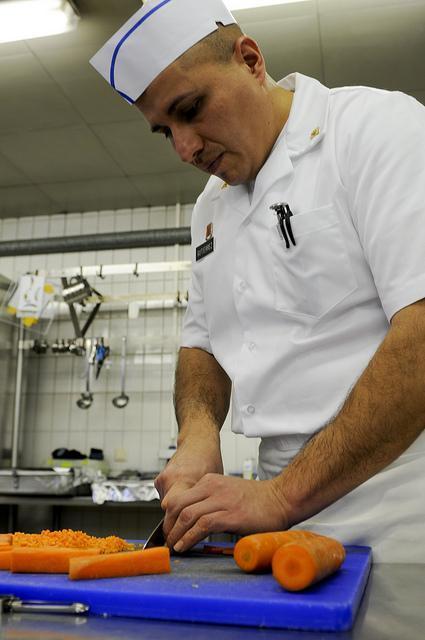How many carrots are in the photo?
Give a very brief answer. 3. 